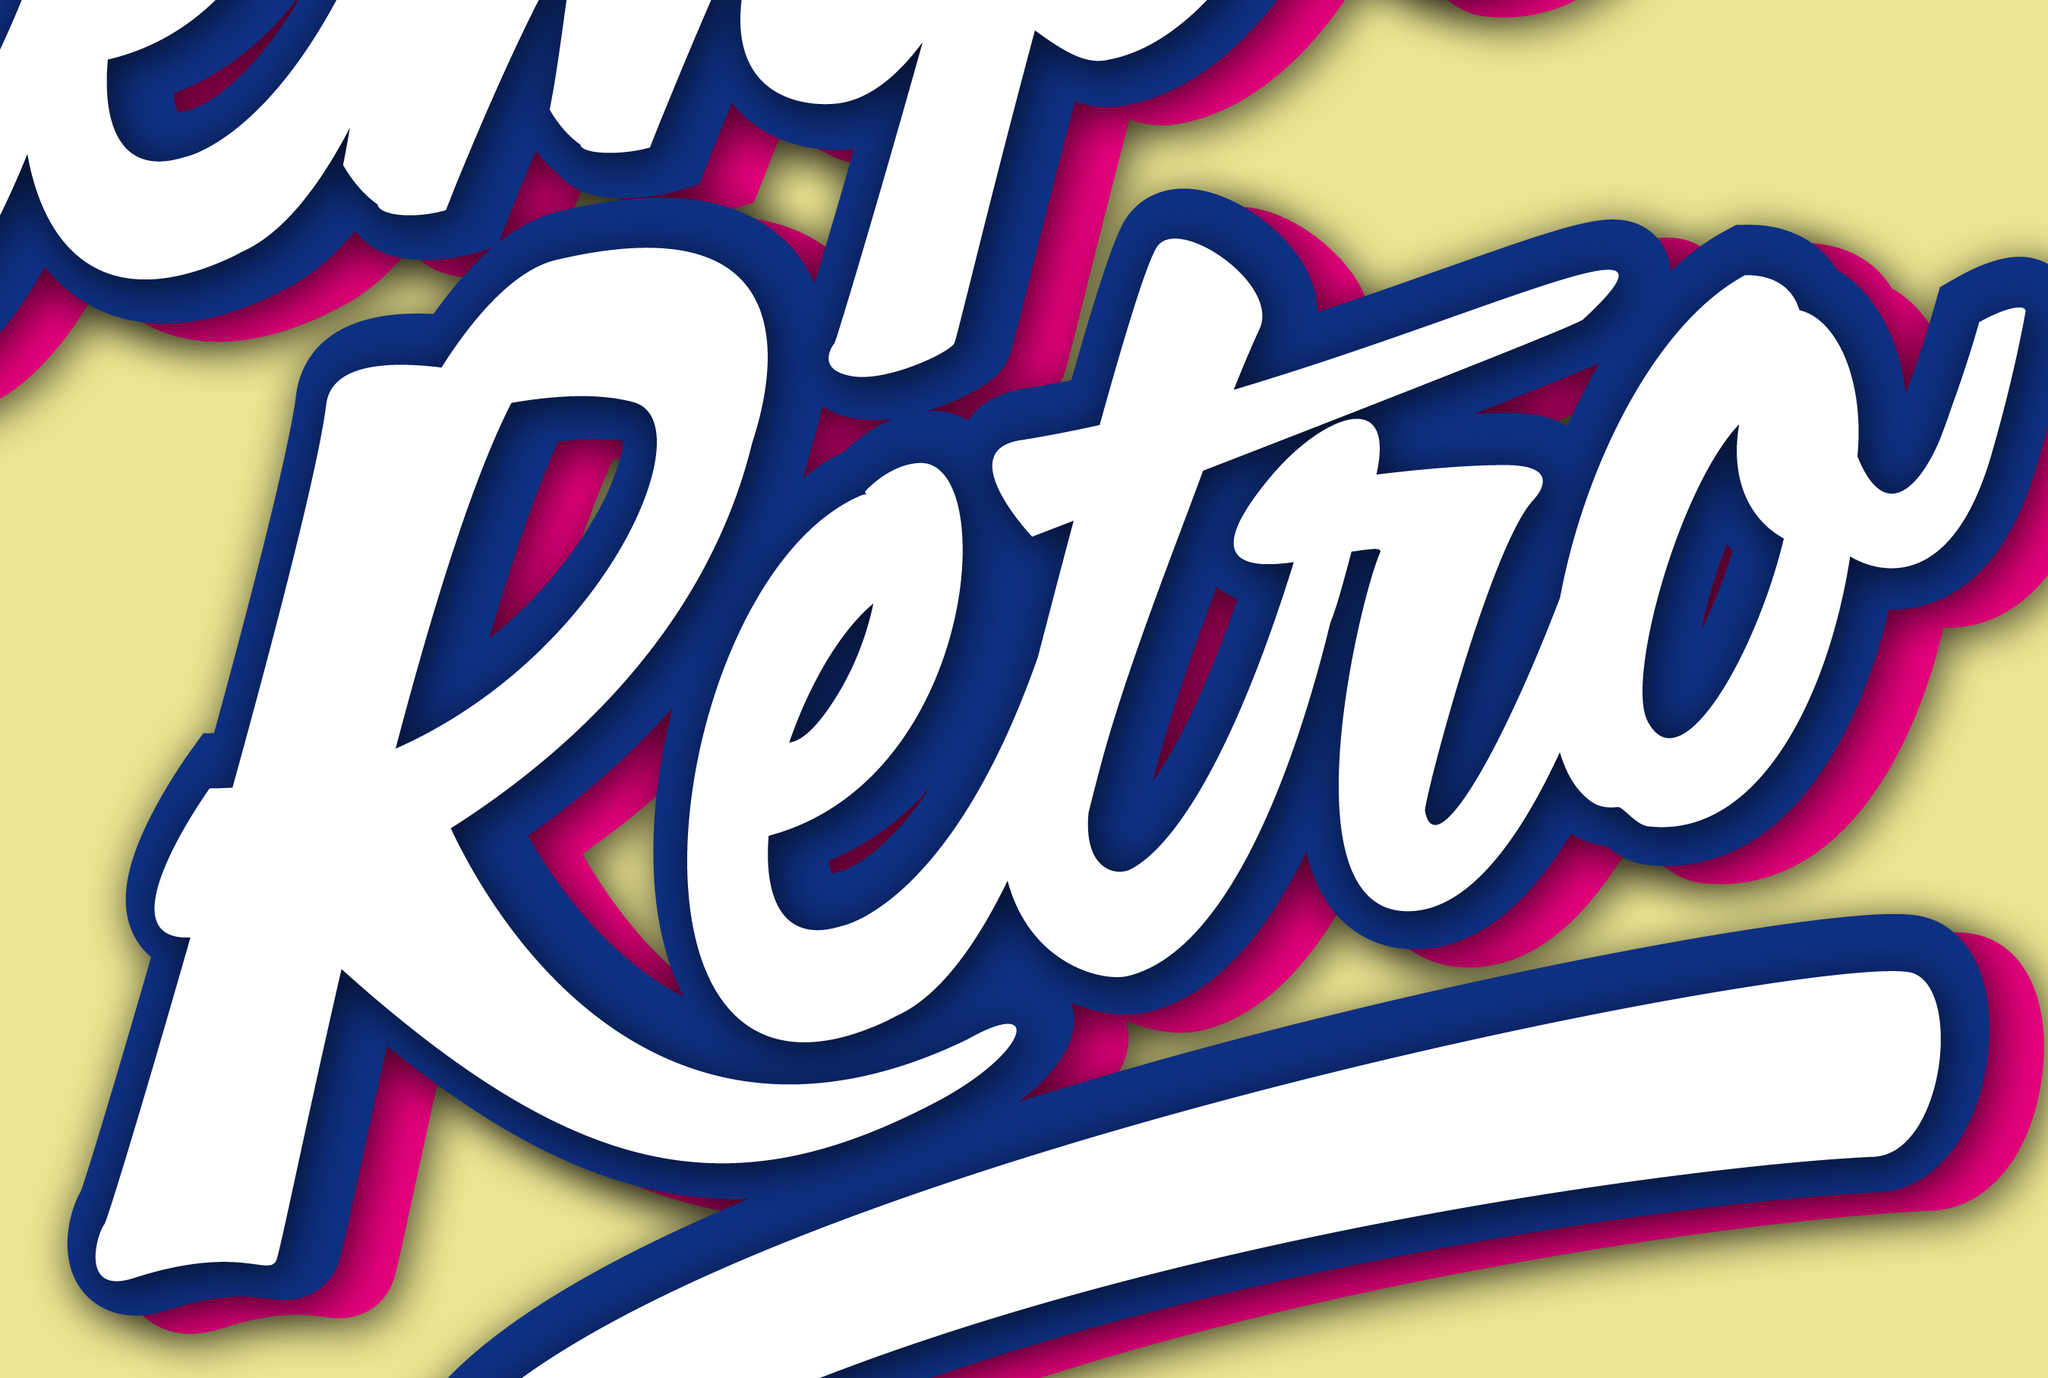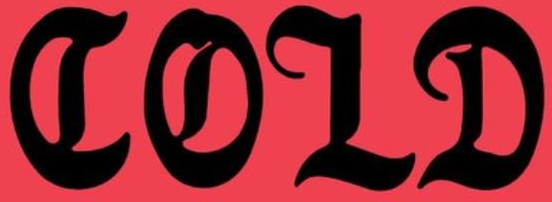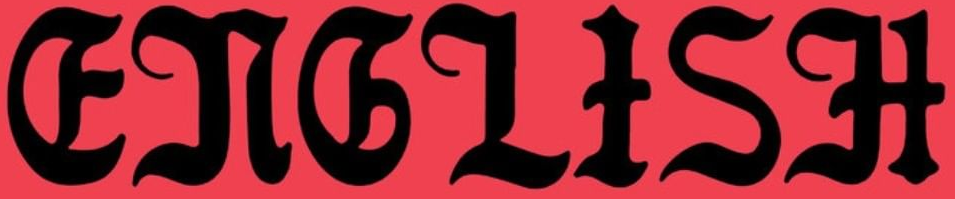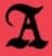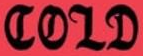What words are shown in these images in order, separated by a semicolon? Retro; COLD; ENGLISH; A; COLD 